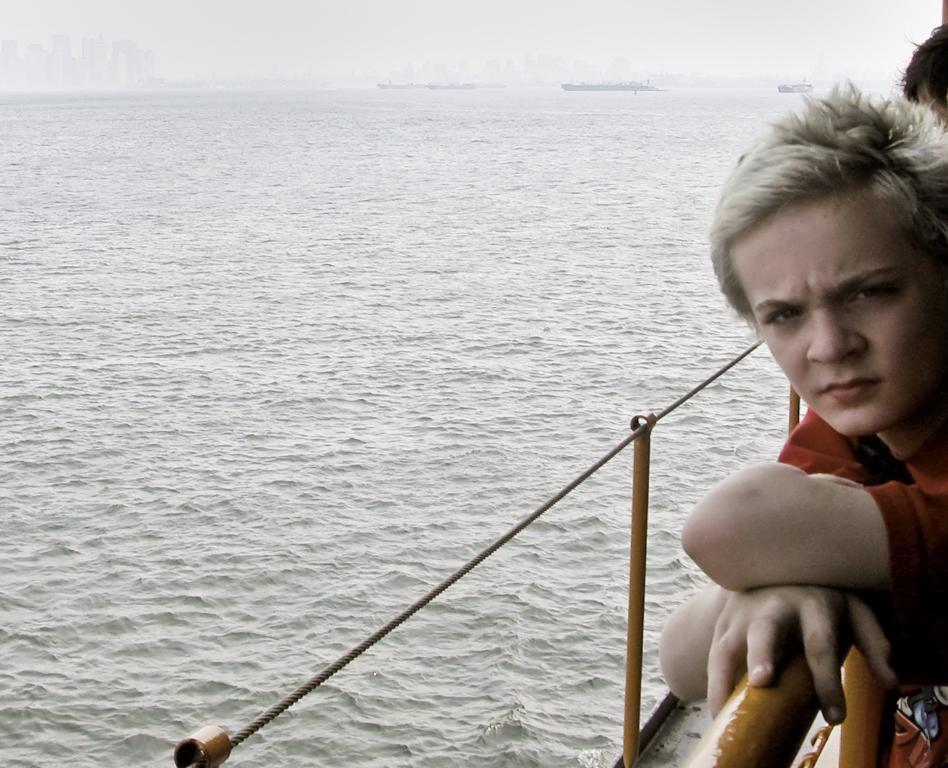Please provide a concise description of this image. In the image there is a boy standing by holding the railing and on the left side there is a water surface. 